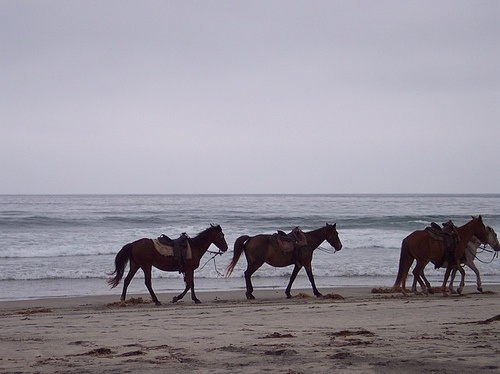Describe the objects in this image and their specific colors. I can see horse in darkgray, black, and gray tones, horse in darkgray, black, and gray tones, horse in darkgray, black, and gray tones, and horse in darkgray, black, and gray tones in this image. 